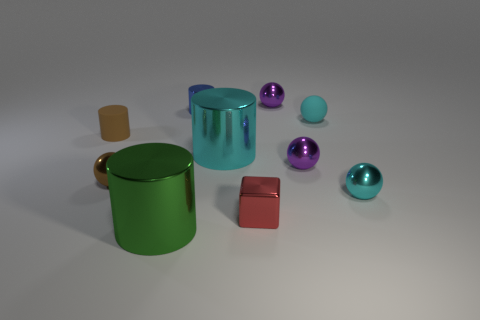Is the tiny red thing the same shape as the small cyan rubber object?
Your response must be concise. No. The purple ball that is to the right of the object behind the tiny blue object is made of what material?
Keep it short and to the point. Metal. What is the material of the small thing that is the same color as the rubber sphere?
Ensure brevity in your answer.  Metal. Does the brown rubber thing have the same size as the brown metallic sphere?
Your answer should be compact. Yes. Is there a brown ball that is right of the big object to the left of the small blue metallic object?
Make the answer very short. No. There is a metallic object that is the same color as the tiny matte cylinder; what size is it?
Provide a short and direct response. Small. What is the shape of the large object that is right of the blue thing?
Ensure brevity in your answer.  Cylinder. There is a cyan metal thing to the left of the small cyan thing in front of the big cyan shiny cylinder; what number of small purple shiny spheres are on the left side of it?
Give a very brief answer. 0. Does the green metal cylinder have the same size as the cylinder on the left side of the green thing?
Keep it short and to the point. No. How big is the rubber thing to the left of the tiny cylinder that is behind the brown rubber cylinder?
Make the answer very short. Small. 